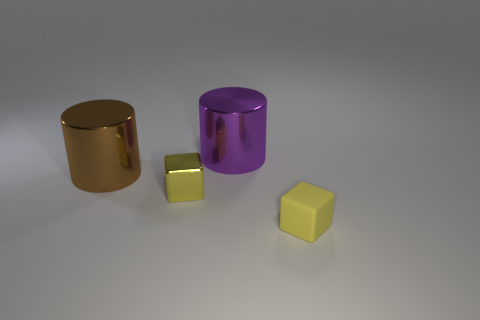If these objects were part of a collection, what sort of collection might that be? If these objects were part of a collection, it might be a designer's set featuring minimalist geometric shapes crafted from various materials, intended to showcase different textures and colors within modern interior decor. 